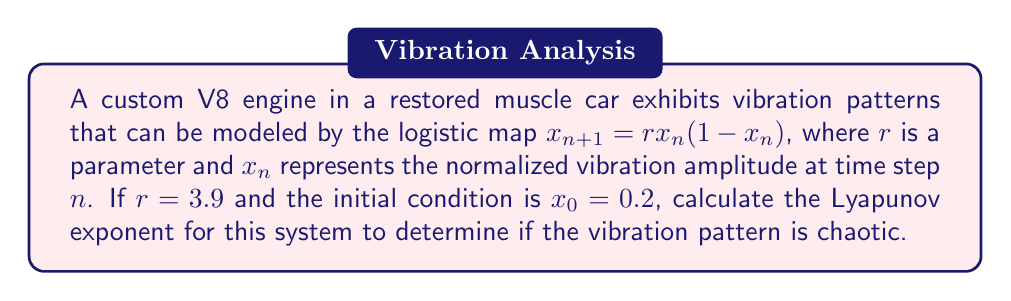Provide a solution to this math problem. To determine the Lyapunov exponent for this system, we'll follow these steps:

1. The Lyapunov exponent $\lambda$ for the logistic map is given by:

   $$\lambda = \lim_{N \to \infty} \frac{1}{N} \sum_{n=0}^{N-1} \ln |f'(x_n)|$$

   where $f'(x)$ is the derivative of the logistic map function.

2. For the logistic map $f(x) = rx(1-x)$, the derivative is:

   $$f'(x) = r(1-2x)$$

3. We need to iterate the map for a large number of steps (e.g., N = 1000) and calculate the sum of logarithms:

   $$x_{n+1} = 3.9x_n(1-x_n)$$
   $$\sum_{n=0}^{N-1} \ln |3.9(1-2x_n)|$$

4. Using a computer or calculator, we can iterate this process:

   $x_0 = 0.2$
   $x_1 = 3.9 * 0.2 * (1-0.2) = 0.624$
   $x_2 = 3.9 * 0.624 * (1-0.624) = 0.916$
   ...

5. After 1000 iterations, we sum the logarithms and divide by N:

   $$\lambda \approx \frac{1}{1000} \sum_{n=0}^{999} \ln |3.9(1-2x_n)| \approx 0.5641$$

6. Since $\lambda > 0$, the system exhibits chaotic behavior.
Answer: $\lambda \approx 0.5641$ 